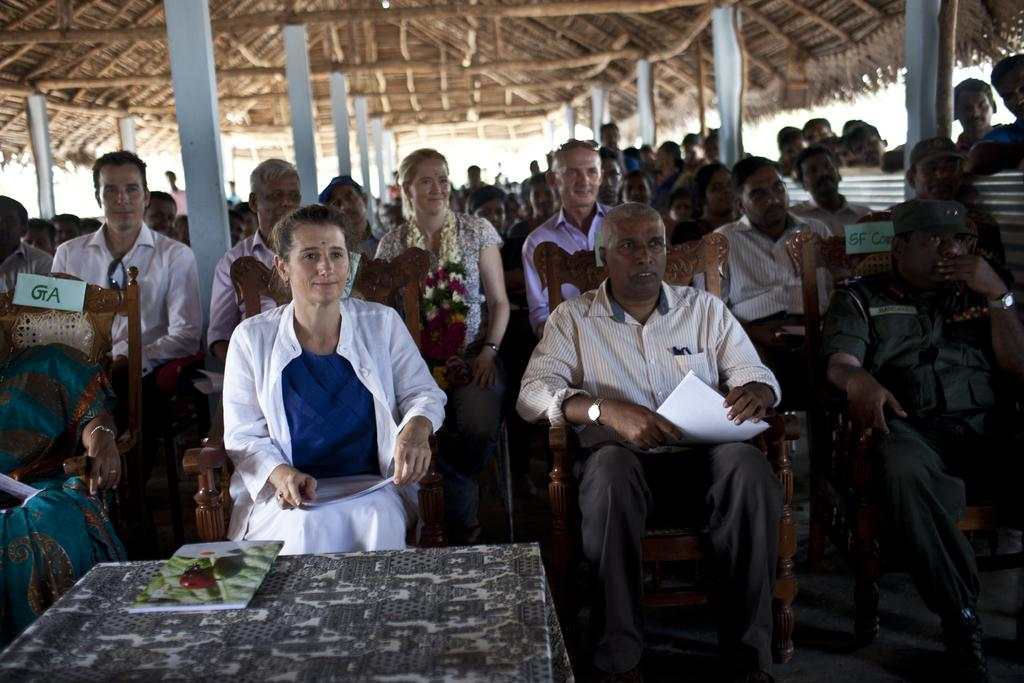What object is placed on the table in the image? There is a book on the table in the image. What are the people in the image doing? The people are sitting on chairs and holding books in the image. What material is used for the roof in the image? There is a thatched roof with pillars in the image. Can you describe the surface in the image? There is an iron sheet in the image. What type of butter is being used to fill the hole in the image? There is no butter or hole present in the image. How does the power source affect the people in the image? There is no mention of a power source in the image, so its effect on the people cannot be determined. 